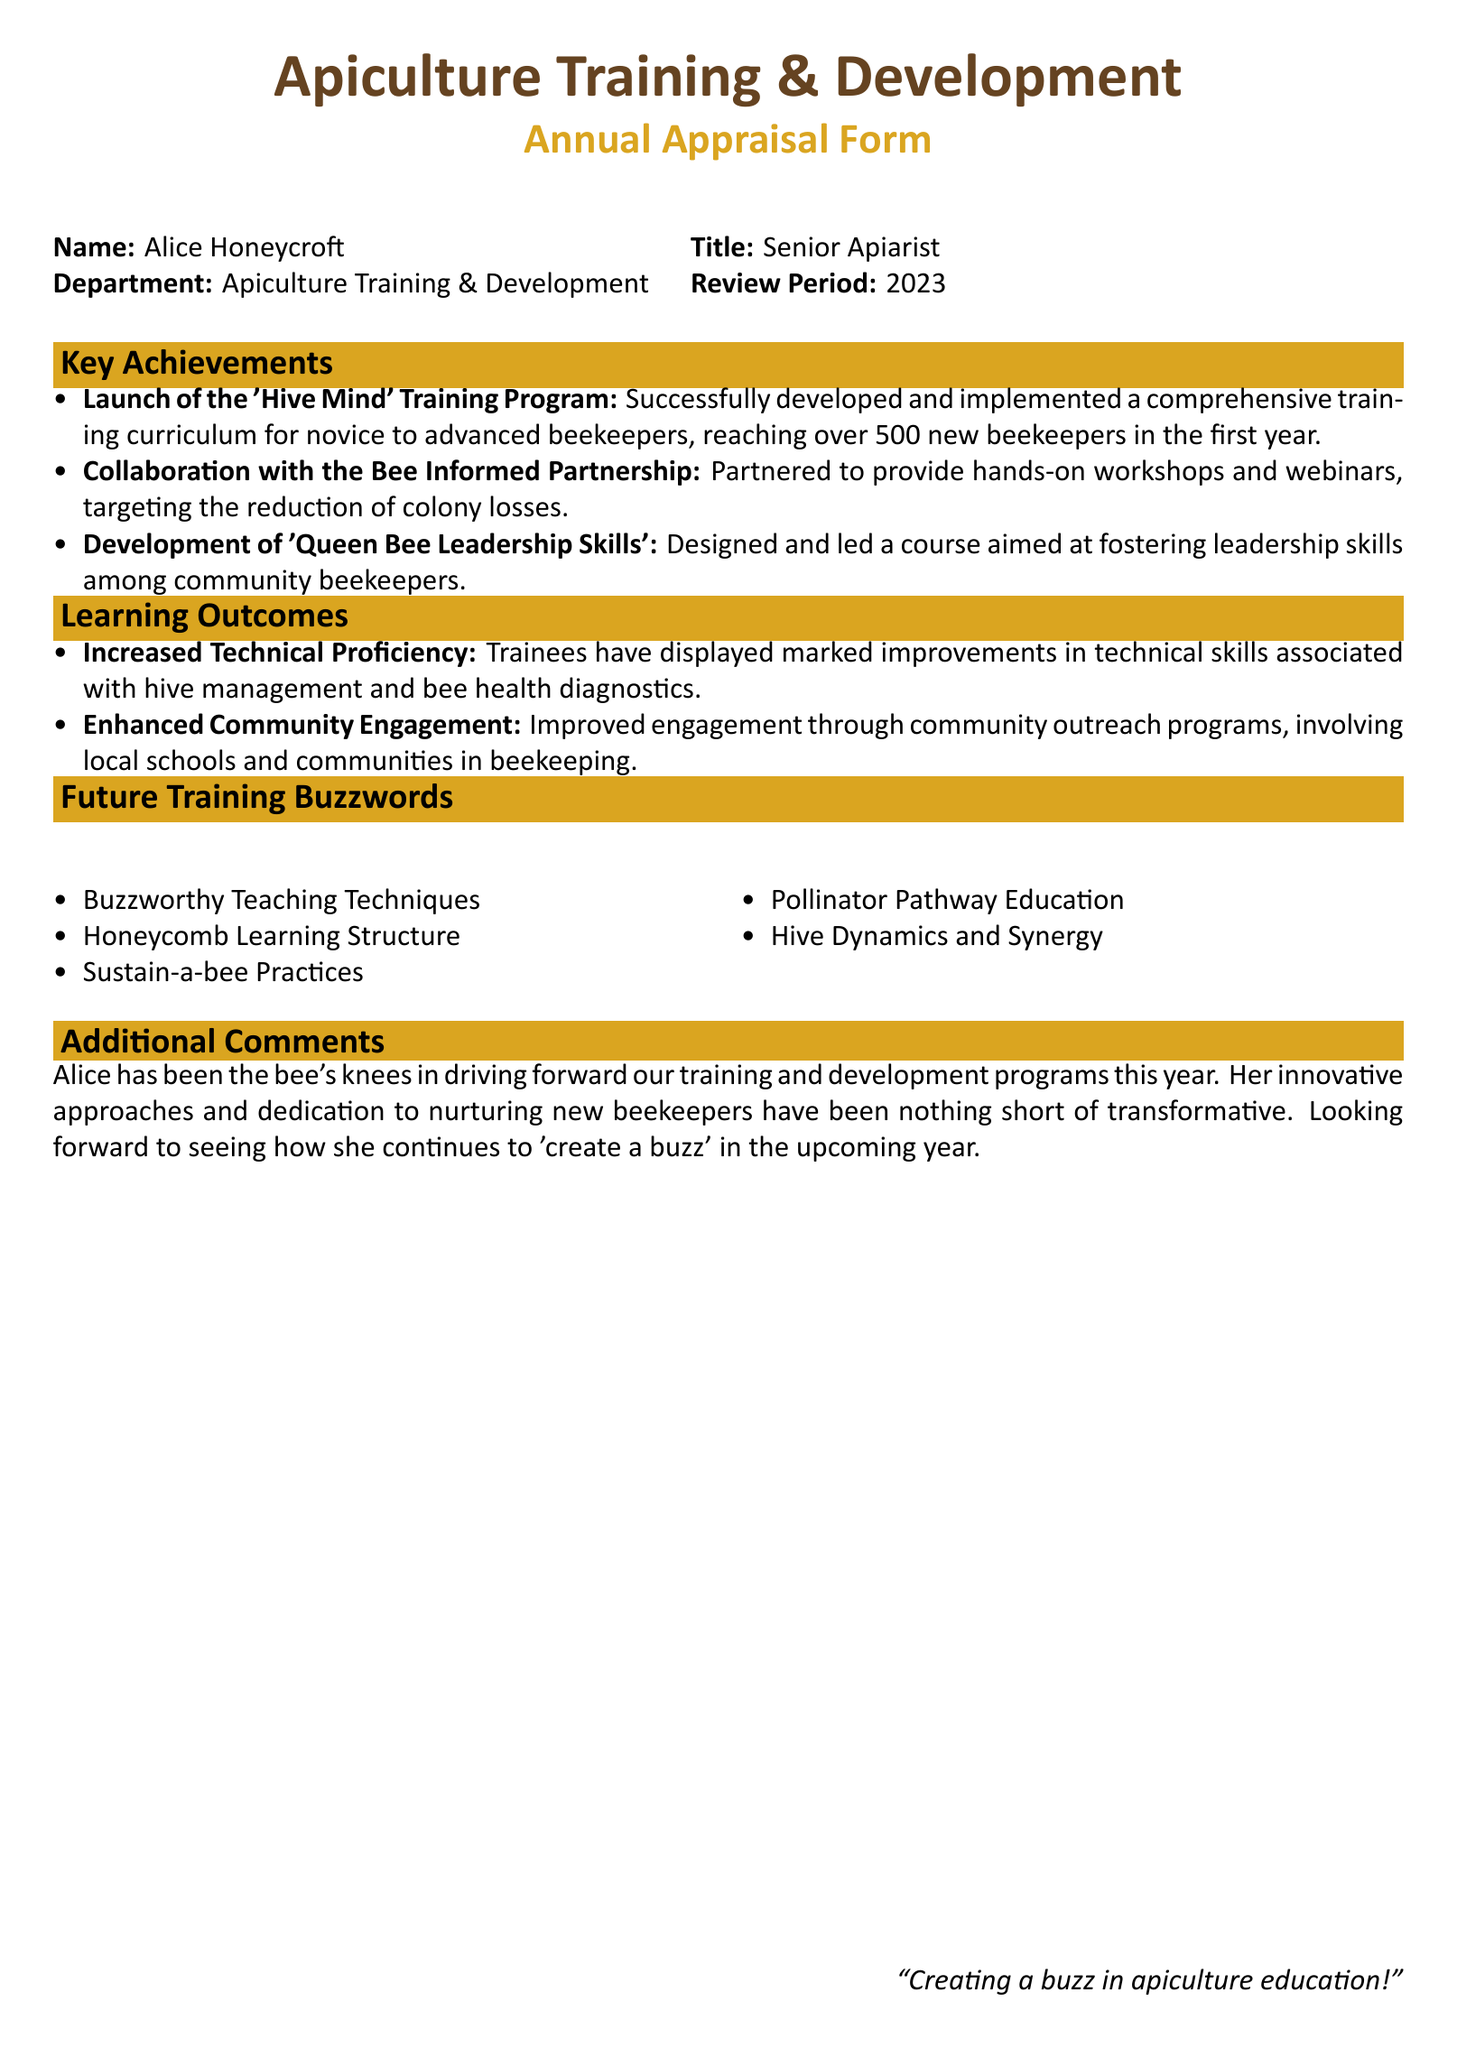What is Alice's title? The document states Alice's title as "Senior Apiarist."
Answer: Senior Apiarist How many new beekeepers were reached? The document mentions that the program reached "over 500 new beekeepers" in the first year.
Answer: over 500 Which organization did Alice collaborate with? The document indicates that Alice collaborated with the "Bee Informed Partnership."
Answer: Bee Informed Partnership What is one of the learning outcomes mentioned? The document highlights "Increased Technical Proficiency" as a learning outcome of the training.
Answer: Increased Technical Proficiency What is a future training buzzword listed? One of the future training buzzwords mentioned in the document is "Sustain-a-bee Practices."
Answer: Sustain-a-bee Practices What year does the review period cover? The document specifies the review period as the year "2023."
Answer: 2023 How did Alice contribute to community engagement? The document states that Alice improved engagement through "community outreach programs."
Answer: community outreach programs What does the additional comment say about Alice's contributions? The additional comment describes Alice's efforts as "the bee's knees" and "transformative."
Answer: the bee's knees What innovative leadership course did Alice develop? The document mentions the course titled "Queen Bee Leadership Skills."
Answer: Queen Bee Leadership Skills 